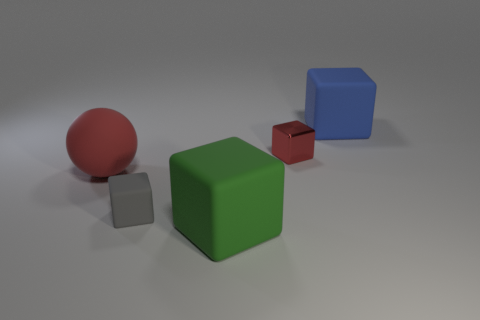Subtract 1 cubes. How many cubes are left? 3 Add 4 tiny brown cubes. How many objects exist? 9 Subtract all spheres. How many objects are left? 4 Add 2 metal blocks. How many metal blocks are left? 3 Add 1 blue blocks. How many blue blocks exist? 2 Subtract 1 red cubes. How many objects are left? 4 Subtract all big rubber cylinders. Subtract all red objects. How many objects are left? 3 